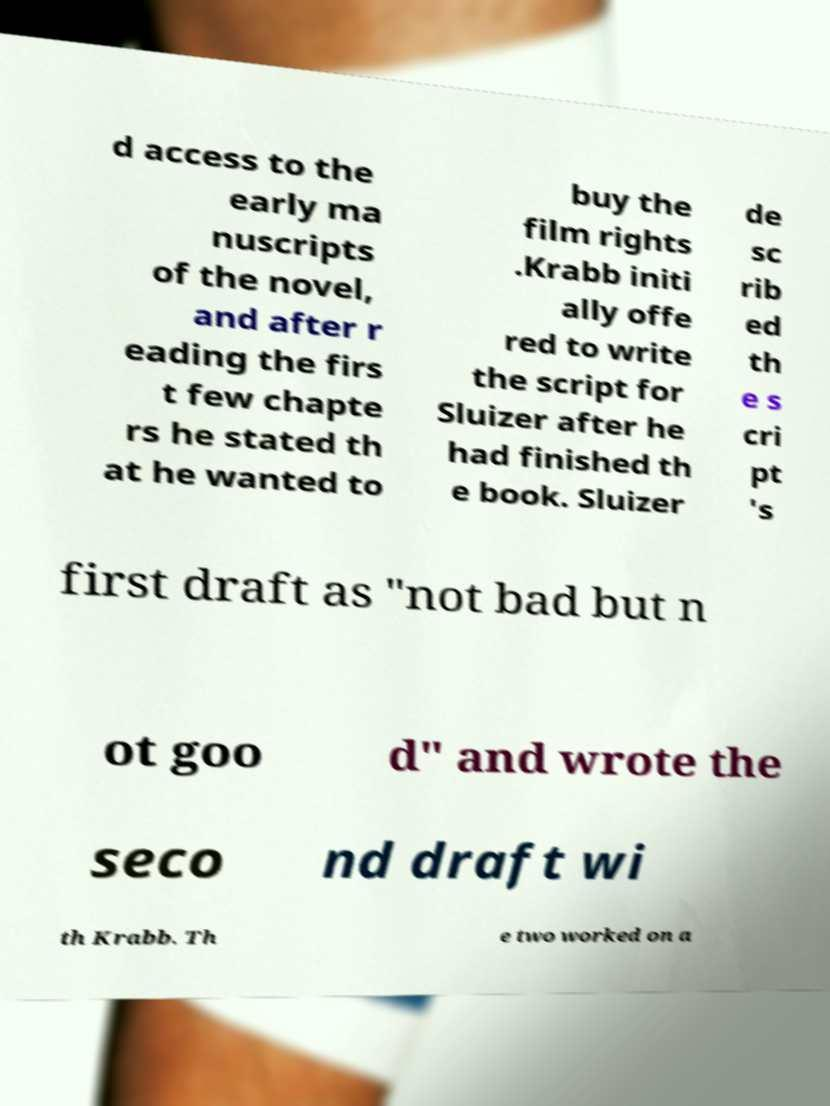Can you read and provide the text displayed in the image?This photo seems to have some interesting text. Can you extract and type it out for me? d access to the early ma nuscripts of the novel, and after r eading the firs t few chapte rs he stated th at he wanted to buy the film rights .Krabb initi ally offe red to write the script for Sluizer after he had finished th e book. Sluizer de sc rib ed th e s cri pt 's first draft as "not bad but n ot goo d" and wrote the seco nd draft wi th Krabb. Th e two worked on a 